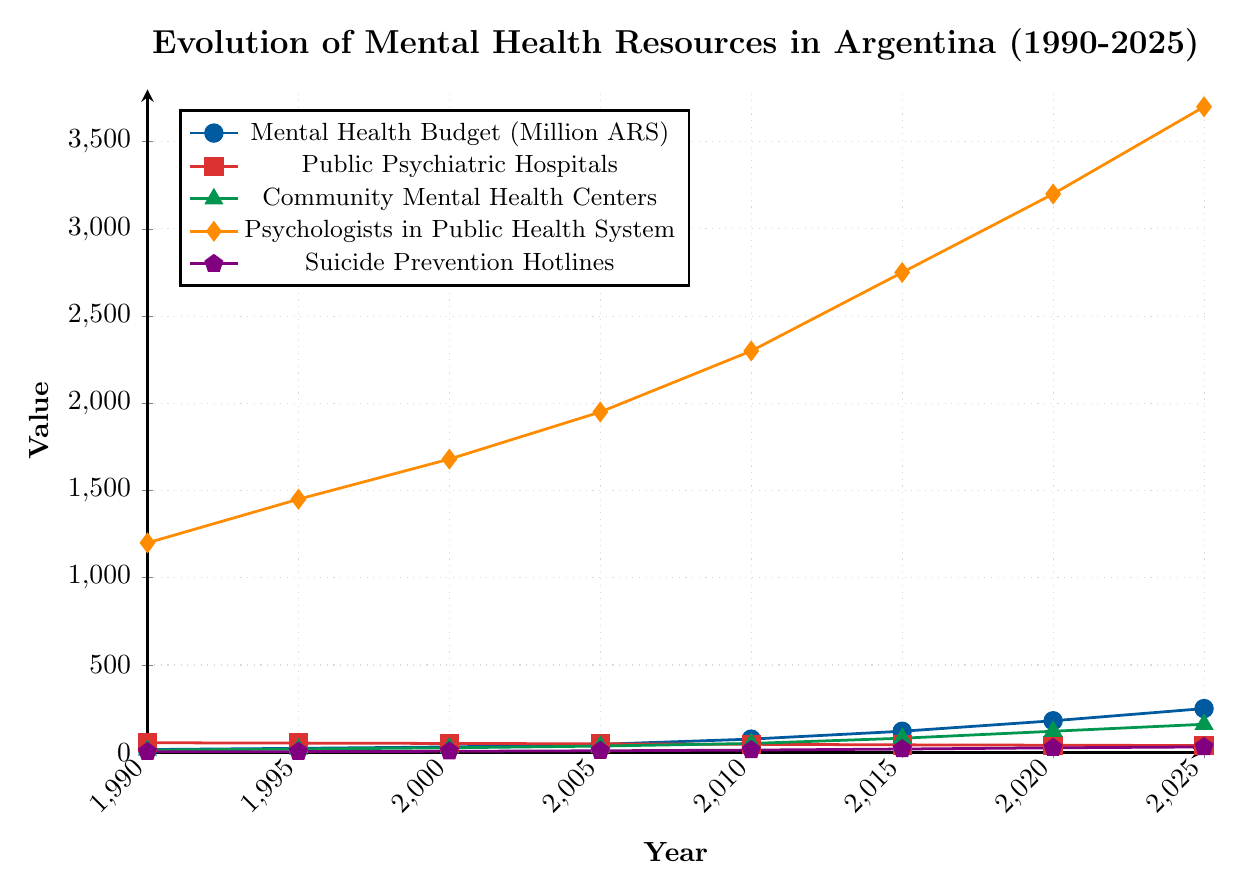What is the trend in the Mental Health Budget from 1990 to 2025? The Mental Health Budget has been steadily increasing over the years. In 1990, it was 15 million ARS, and it rose to 250 million ARS by 2025.
Answer: Increasing How many years did it take for the number of Community Mental Health Centers to increase from 12 to 160? The number of Community Mental Health Centers was 12 in 1990 and increased to 160 by 2025. Subtracting the starting year from the ending year, 2025 - 1990 = 35 years.
Answer: 35 years Which category shows a decreasing trend from 1990 to 2025? The number of Public Psychiatric Hospitals shows a decreasing trend, starting from 54 in 1990 to 38 in 2025.
Answer: Public Psychiatric Hospitals Between 2010 and 2020, how many additional Psychologists were added to the Public Health System? In 2010, there were 2300 Psychologists, and by 2020, this number rose to 3200. Subtracting the starting value from the ending value, 3200 - 2300 = 900 additional Psychologists.
Answer: 900 What is the percentage increase in the Suicide Prevention Hotlines between 1990 and 2025? Initially, there were 2 hotlines in 1990, and this number increased to 30 by 2025. The increase is 30 - 2 = 28 hotlines. The percentage increase is (28 / 2) * 100 = 1400%.
Answer: 1400% Which visual attribute helps distinguish the Mental Health Budget line from others in the figure? The Mental Health Budget line is distinguished by its blue color and circular markers.
Answer: Blue color and circular markers In what year do the number of Community Mental Health Centers surpass the number of Public Psychiatric Hospitals? The number of Community Mental Health Centers surpasses the number of Public Psychiatric Hospitals in 2015. Before 2015, there are fewer Community Mental Health Centers, and in 2015, they become equal, with more Community Mental Health Centers seen afterward.
Answer: 2015 What is the average number of Public Psychiatric Hospitals from 1990 to 2025? Summing the number of Public Psychiatric Hospitals from 1990 (54), 1995 (52), 2000 (50), 2005 (48), 2010 (45), 2015 (42), 2020 (40), and 2025 (38) gives 369. Dividing by the number of years (8) results in an average of 369 / 8 = 46.125.
Answer: 46.125 What is the ratio of Psychologists in the Public Health System to the number of Suicide Prevention Hotlines in 2025? In 2025, there are 3700 Psychologists and 30 Suicide Prevention Hotlines. The ratio is 3700 / 30 = 123.33.
Answer: 123.33 